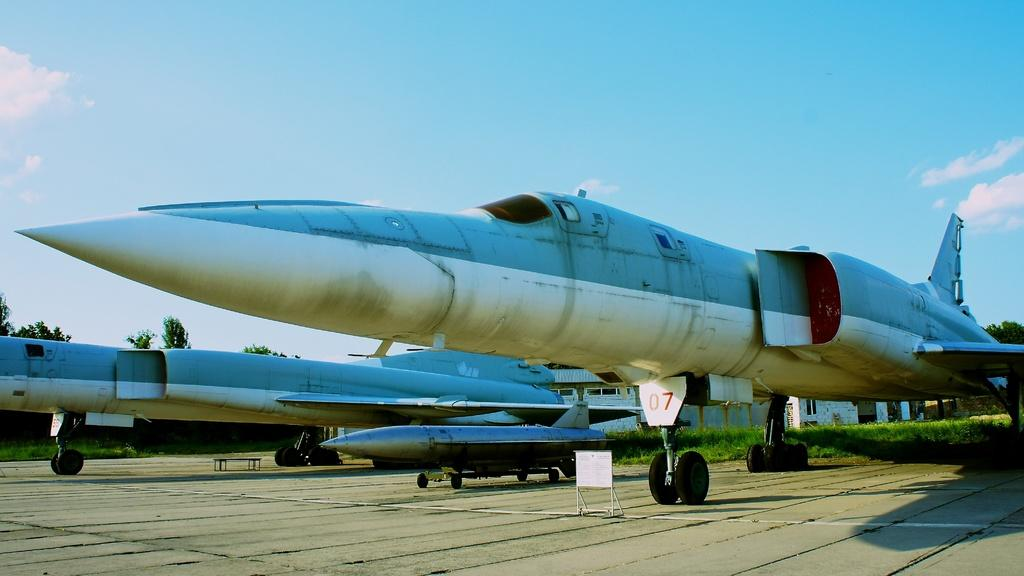<image>
Offer a succinct explanation of the picture presented. Jet on the ground with 07 by the wheel 